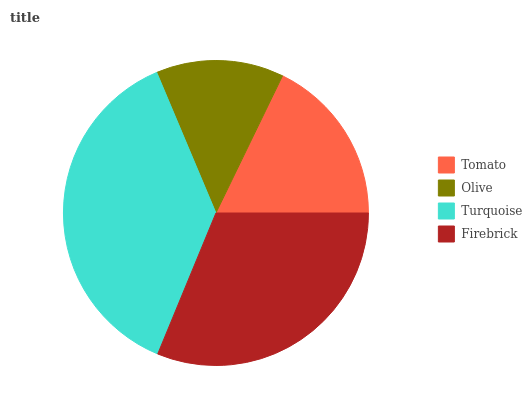Is Olive the minimum?
Answer yes or no. Yes. Is Turquoise the maximum?
Answer yes or no. Yes. Is Turquoise the minimum?
Answer yes or no. No. Is Olive the maximum?
Answer yes or no. No. Is Turquoise greater than Olive?
Answer yes or no. Yes. Is Olive less than Turquoise?
Answer yes or no. Yes. Is Olive greater than Turquoise?
Answer yes or no. No. Is Turquoise less than Olive?
Answer yes or no. No. Is Firebrick the high median?
Answer yes or no. Yes. Is Tomato the low median?
Answer yes or no. Yes. Is Turquoise the high median?
Answer yes or no. No. Is Turquoise the low median?
Answer yes or no. No. 